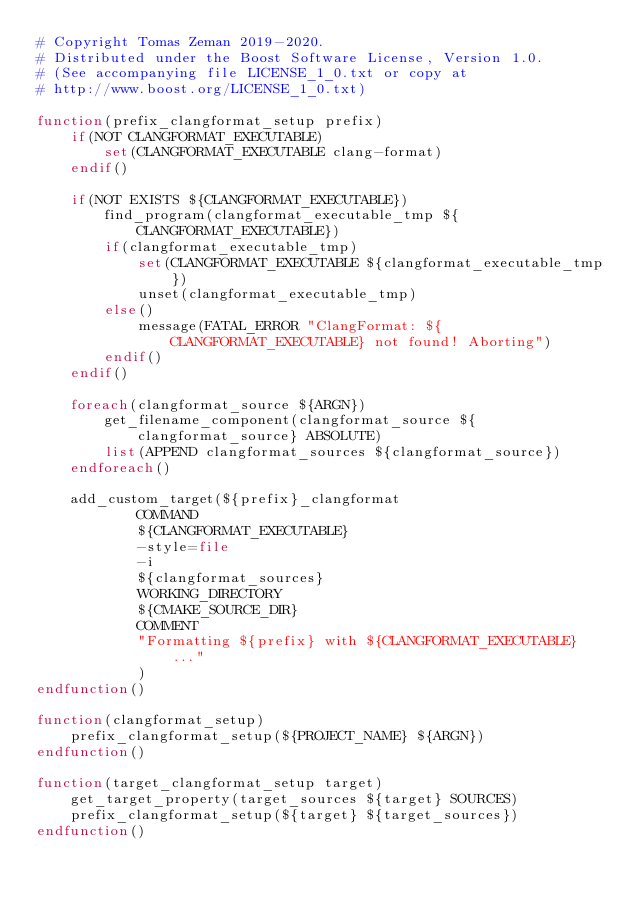Convert code to text. <code><loc_0><loc_0><loc_500><loc_500><_CMake_># Copyright Tomas Zeman 2019-2020.
# Distributed under the Boost Software License, Version 1.0.
# (See accompanying file LICENSE_1_0.txt or copy at
# http://www.boost.org/LICENSE_1_0.txt)

function(prefix_clangformat_setup prefix)
    if(NOT CLANGFORMAT_EXECUTABLE)
        set(CLANGFORMAT_EXECUTABLE clang-format)
    endif()

    if(NOT EXISTS ${CLANGFORMAT_EXECUTABLE})
        find_program(clangformat_executable_tmp ${CLANGFORMAT_EXECUTABLE})
        if(clangformat_executable_tmp)
            set(CLANGFORMAT_EXECUTABLE ${clangformat_executable_tmp})
            unset(clangformat_executable_tmp)
        else()
            message(FATAL_ERROR "ClangFormat: ${CLANGFORMAT_EXECUTABLE} not found! Aborting")
        endif()
    endif()

    foreach(clangformat_source ${ARGN})
        get_filename_component(clangformat_source ${clangformat_source} ABSOLUTE)
        list(APPEND clangformat_sources ${clangformat_source})
    endforeach()

    add_custom_target(${prefix}_clangformat
            COMMAND
            ${CLANGFORMAT_EXECUTABLE}
            -style=file
            -i
            ${clangformat_sources}
            WORKING_DIRECTORY
            ${CMAKE_SOURCE_DIR}
            COMMENT
            "Formatting ${prefix} with ${CLANGFORMAT_EXECUTABLE} ..."
            )
endfunction()

function(clangformat_setup)
    prefix_clangformat_setup(${PROJECT_NAME} ${ARGN})
endfunction()

function(target_clangformat_setup target)
    get_target_property(target_sources ${target} SOURCES)
    prefix_clangformat_setup(${target} ${target_sources})
endfunction()</code> 